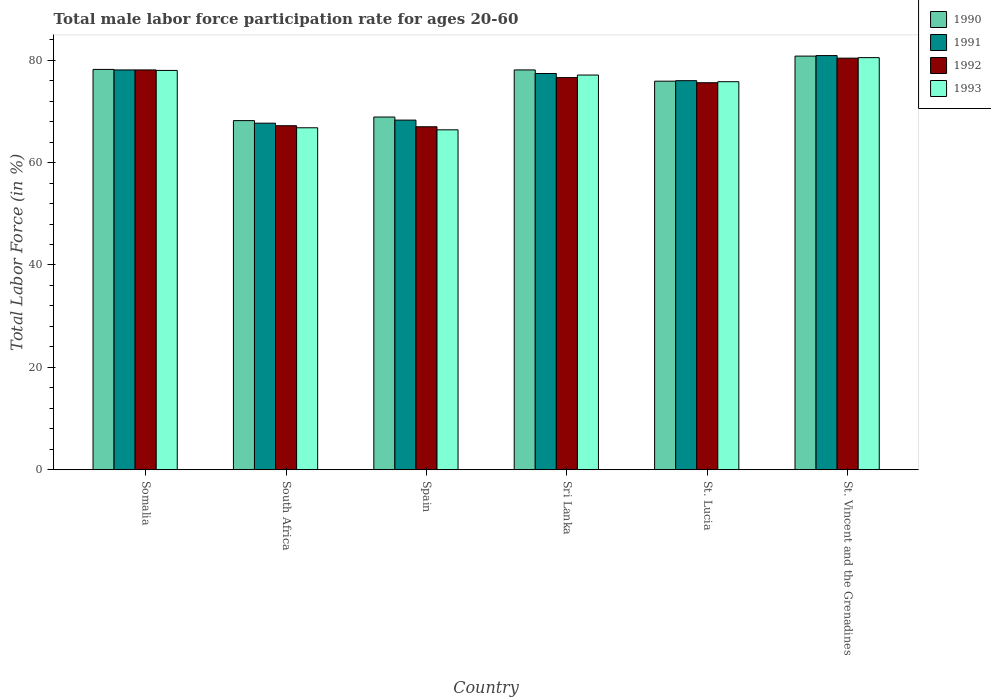How many groups of bars are there?
Keep it short and to the point. 6. What is the label of the 3rd group of bars from the left?
Make the answer very short. Spain. What is the male labor force participation rate in 1991 in Sri Lanka?
Keep it short and to the point. 77.4. Across all countries, what is the maximum male labor force participation rate in 1991?
Provide a short and direct response. 80.9. Across all countries, what is the minimum male labor force participation rate in 1990?
Your answer should be very brief. 68.2. In which country was the male labor force participation rate in 1991 maximum?
Your answer should be very brief. St. Vincent and the Grenadines. In which country was the male labor force participation rate in 1990 minimum?
Your answer should be compact. South Africa. What is the total male labor force participation rate in 1991 in the graph?
Provide a succinct answer. 448.4. What is the difference between the male labor force participation rate in 1990 in South Africa and that in St. Lucia?
Offer a terse response. -7.7. What is the difference between the male labor force participation rate in 1992 in St. Vincent and the Grenadines and the male labor force participation rate in 1990 in South Africa?
Provide a succinct answer. 12.2. What is the average male labor force participation rate in 1993 per country?
Make the answer very short. 74.1. What is the difference between the male labor force participation rate of/in 1990 and male labor force participation rate of/in 1991 in Spain?
Offer a very short reply. 0.6. In how many countries, is the male labor force participation rate in 1993 greater than 12 %?
Offer a terse response. 6. What is the ratio of the male labor force participation rate in 1990 in Somalia to that in Sri Lanka?
Your response must be concise. 1. Is the difference between the male labor force participation rate in 1990 in Spain and Sri Lanka greater than the difference between the male labor force participation rate in 1991 in Spain and Sri Lanka?
Offer a terse response. No. What is the difference between the highest and the second highest male labor force participation rate in 1990?
Provide a short and direct response. 2.7. What is the difference between the highest and the lowest male labor force participation rate in 1990?
Your answer should be compact. 12.6. In how many countries, is the male labor force participation rate in 1991 greater than the average male labor force participation rate in 1991 taken over all countries?
Your answer should be very brief. 4. Is it the case that in every country, the sum of the male labor force participation rate in 1990 and male labor force participation rate in 1993 is greater than the sum of male labor force participation rate in 1991 and male labor force participation rate in 1992?
Provide a short and direct response. No. What does the 4th bar from the left in Sri Lanka represents?
Ensure brevity in your answer.  1993. What does the 3rd bar from the right in St. Vincent and the Grenadines represents?
Offer a very short reply. 1991. Is it the case that in every country, the sum of the male labor force participation rate in 1993 and male labor force participation rate in 1991 is greater than the male labor force participation rate in 1992?
Ensure brevity in your answer.  Yes. Are all the bars in the graph horizontal?
Keep it short and to the point. No. What is the difference between two consecutive major ticks on the Y-axis?
Give a very brief answer. 20. Where does the legend appear in the graph?
Give a very brief answer. Top right. How are the legend labels stacked?
Offer a terse response. Vertical. What is the title of the graph?
Your answer should be very brief. Total male labor force participation rate for ages 20-60. Does "1998" appear as one of the legend labels in the graph?
Provide a succinct answer. No. What is the label or title of the X-axis?
Offer a terse response. Country. What is the label or title of the Y-axis?
Give a very brief answer. Total Labor Force (in %). What is the Total Labor Force (in %) in 1990 in Somalia?
Ensure brevity in your answer.  78.2. What is the Total Labor Force (in %) of 1991 in Somalia?
Your answer should be compact. 78.1. What is the Total Labor Force (in %) of 1992 in Somalia?
Provide a succinct answer. 78.1. What is the Total Labor Force (in %) of 1990 in South Africa?
Give a very brief answer. 68.2. What is the Total Labor Force (in %) in 1991 in South Africa?
Offer a very short reply. 67.7. What is the Total Labor Force (in %) in 1992 in South Africa?
Ensure brevity in your answer.  67.2. What is the Total Labor Force (in %) in 1993 in South Africa?
Offer a very short reply. 66.8. What is the Total Labor Force (in %) of 1990 in Spain?
Provide a succinct answer. 68.9. What is the Total Labor Force (in %) in 1991 in Spain?
Ensure brevity in your answer.  68.3. What is the Total Labor Force (in %) in 1993 in Spain?
Offer a very short reply. 66.4. What is the Total Labor Force (in %) of 1990 in Sri Lanka?
Provide a succinct answer. 78.1. What is the Total Labor Force (in %) in 1991 in Sri Lanka?
Provide a short and direct response. 77.4. What is the Total Labor Force (in %) of 1992 in Sri Lanka?
Offer a very short reply. 76.6. What is the Total Labor Force (in %) of 1993 in Sri Lanka?
Give a very brief answer. 77.1. What is the Total Labor Force (in %) in 1990 in St. Lucia?
Your answer should be very brief. 75.9. What is the Total Labor Force (in %) in 1991 in St. Lucia?
Give a very brief answer. 76. What is the Total Labor Force (in %) of 1992 in St. Lucia?
Your response must be concise. 75.6. What is the Total Labor Force (in %) of 1993 in St. Lucia?
Your answer should be very brief. 75.8. What is the Total Labor Force (in %) in 1990 in St. Vincent and the Grenadines?
Offer a terse response. 80.8. What is the Total Labor Force (in %) in 1991 in St. Vincent and the Grenadines?
Ensure brevity in your answer.  80.9. What is the Total Labor Force (in %) of 1992 in St. Vincent and the Grenadines?
Make the answer very short. 80.4. What is the Total Labor Force (in %) of 1993 in St. Vincent and the Grenadines?
Your answer should be very brief. 80.5. Across all countries, what is the maximum Total Labor Force (in %) of 1990?
Provide a short and direct response. 80.8. Across all countries, what is the maximum Total Labor Force (in %) of 1991?
Your response must be concise. 80.9. Across all countries, what is the maximum Total Labor Force (in %) of 1992?
Ensure brevity in your answer.  80.4. Across all countries, what is the maximum Total Labor Force (in %) in 1993?
Provide a succinct answer. 80.5. Across all countries, what is the minimum Total Labor Force (in %) in 1990?
Your response must be concise. 68.2. Across all countries, what is the minimum Total Labor Force (in %) in 1991?
Ensure brevity in your answer.  67.7. Across all countries, what is the minimum Total Labor Force (in %) in 1992?
Your answer should be compact. 67. Across all countries, what is the minimum Total Labor Force (in %) of 1993?
Your answer should be very brief. 66.4. What is the total Total Labor Force (in %) in 1990 in the graph?
Make the answer very short. 450.1. What is the total Total Labor Force (in %) of 1991 in the graph?
Provide a succinct answer. 448.4. What is the total Total Labor Force (in %) of 1992 in the graph?
Your answer should be compact. 444.9. What is the total Total Labor Force (in %) of 1993 in the graph?
Ensure brevity in your answer.  444.6. What is the difference between the Total Labor Force (in %) of 1990 in Somalia and that in South Africa?
Make the answer very short. 10. What is the difference between the Total Labor Force (in %) in 1992 in Somalia and that in South Africa?
Provide a succinct answer. 10.9. What is the difference between the Total Labor Force (in %) in 1990 in Somalia and that in Spain?
Keep it short and to the point. 9.3. What is the difference between the Total Labor Force (in %) of 1992 in Somalia and that in Spain?
Make the answer very short. 11.1. What is the difference between the Total Labor Force (in %) of 1990 in Somalia and that in Sri Lanka?
Your answer should be very brief. 0.1. What is the difference between the Total Labor Force (in %) of 1991 in Somalia and that in Sri Lanka?
Give a very brief answer. 0.7. What is the difference between the Total Labor Force (in %) of 1992 in Somalia and that in Sri Lanka?
Your answer should be compact. 1.5. What is the difference between the Total Labor Force (in %) of 1993 in Somalia and that in Sri Lanka?
Give a very brief answer. 0.9. What is the difference between the Total Labor Force (in %) in 1991 in Somalia and that in St. Lucia?
Offer a terse response. 2.1. What is the difference between the Total Labor Force (in %) in 1992 in Somalia and that in St. Lucia?
Your answer should be compact. 2.5. What is the difference between the Total Labor Force (in %) of 1993 in Somalia and that in St. Lucia?
Provide a short and direct response. 2.2. What is the difference between the Total Labor Force (in %) of 1990 in Somalia and that in St. Vincent and the Grenadines?
Ensure brevity in your answer.  -2.6. What is the difference between the Total Labor Force (in %) in 1990 in South Africa and that in Spain?
Provide a short and direct response. -0.7. What is the difference between the Total Labor Force (in %) in 1990 in South Africa and that in Sri Lanka?
Provide a short and direct response. -9.9. What is the difference between the Total Labor Force (in %) in 1991 in South Africa and that in Sri Lanka?
Give a very brief answer. -9.7. What is the difference between the Total Labor Force (in %) in 1992 in South Africa and that in Sri Lanka?
Provide a short and direct response. -9.4. What is the difference between the Total Labor Force (in %) of 1993 in South Africa and that in Sri Lanka?
Provide a short and direct response. -10.3. What is the difference between the Total Labor Force (in %) of 1991 in South Africa and that in St. Lucia?
Provide a short and direct response. -8.3. What is the difference between the Total Labor Force (in %) of 1990 in South Africa and that in St. Vincent and the Grenadines?
Your answer should be very brief. -12.6. What is the difference between the Total Labor Force (in %) in 1991 in South Africa and that in St. Vincent and the Grenadines?
Ensure brevity in your answer.  -13.2. What is the difference between the Total Labor Force (in %) of 1992 in South Africa and that in St. Vincent and the Grenadines?
Offer a terse response. -13.2. What is the difference between the Total Labor Force (in %) of 1993 in South Africa and that in St. Vincent and the Grenadines?
Your answer should be compact. -13.7. What is the difference between the Total Labor Force (in %) of 1990 in Spain and that in Sri Lanka?
Your response must be concise. -9.2. What is the difference between the Total Labor Force (in %) of 1991 in Spain and that in Sri Lanka?
Your answer should be very brief. -9.1. What is the difference between the Total Labor Force (in %) in 1992 in Spain and that in Sri Lanka?
Give a very brief answer. -9.6. What is the difference between the Total Labor Force (in %) in 1993 in Spain and that in Sri Lanka?
Offer a very short reply. -10.7. What is the difference between the Total Labor Force (in %) in 1990 in Spain and that in St. Lucia?
Your answer should be compact. -7. What is the difference between the Total Labor Force (in %) in 1991 in Spain and that in St. Lucia?
Keep it short and to the point. -7.7. What is the difference between the Total Labor Force (in %) of 1992 in Spain and that in St. Lucia?
Provide a succinct answer. -8.6. What is the difference between the Total Labor Force (in %) in 1993 in Spain and that in St. Lucia?
Make the answer very short. -9.4. What is the difference between the Total Labor Force (in %) in 1990 in Spain and that in St. Vincent and the Grenadines?
Your answer should be compact. -11.9. What is the difference between the Total Labor Force (in %) of 1991 in Spain and that in St. Vincent and the Grenadines?
Provide a short and direct response. -12.6. What is the difference between the Total Labor Force (in %) of 1992 in Spain and that in St. Vincent and the Grenadines?
Your answer should be very brief. -13.4. What is the difference between the Total Labor Force (in %) of 1993 in Spain and that in St. Vincent and the Grenadines?
Ensure brevity in your answer.  -14.1. What is the difference between the Total Labor Force (in %) of 1992 in Sri Lanka and that in St. Vincent and the Grenadines?
Provide a succinct answer. -3.8. What is the difference between the Total Labor Force (in %) of 1993 in Sri Lanka and that in St. Vincent and the Grenadines?
Offer a terse response. -3.4. What is the difference between the Total Labor Force (in %) of 1990 in St. Lucia and that in St. Vincent and the Grenadines?
Keep it short and to the point. -4.9. What is the difference between the Total Labor Force (in %) in 1993 in St. Lucia and that in St. Vincent and the Grenadines?
Provide a succinct answer. -4.7. What is the difference between the Total Labor Force (in %) of 1990 in Somalia and the Total Labor Force (in %) of 1992 in South Africa?
Your answer should be very brief. 11. What is the difference between the Total Labor Force (in %) of 1990 in Somalia and the Total Labor Force (in %) of 1993 in Spain?
Provide a short and direct response. 11.8. What is the difference between the Total Labor Force (in %) of 1992 in Somalia and the Total Labor Force (in %) of 1993 in Spain?
Make the answer very short. 11.7. What is the difference between the Total Labor Force (in %) of 1990 in Somalia and the Total Labor Force (in %) of 1993 in Sri Lanka?
Provide a succinct answer. 1.1. What is the difference between the Total Labor Force (in %) in 1991 in Somalia and the Total Labor Force (in %) in 1992 in Sri Lanka?
Ensure brevity in your answer.  1.5. What is the difference between the Total Labor Force (in %) of 1991 in Somalia and the Total Labor Force (in %) of 1993 in Sri Lanka?
Offer a terse response. 1. What is the difference between the Total Labor Force (in %) of 1990 in Somalia and the Total Labor Force (in %) of 1991 in St. Lucia?
Offer a very short reply. 2.2. What is the difference between the Total Labor Force (in %) of 1990 in Somalia and the Total Labor Force (in %) of 1992 in St. Lucia?
Provide a succinct answer. 2.6. What is the difference between the Total Labor Force (in %) of 1992 in Somalia and the Total Labor Force (in %) of 1993 in St. Lucia?
Make the answer very short. 2.3. What is the difference between the Total Labor Force (in %) of 1990 in Somalia and the Total Labor Force (in %) of 1991 in St. Vincent and the Grenadines?
Offer a very short reply. -2.7. What is the difference between the Total Labor Force (in %) in 1990 in Somalia and the Total Labor Force (in %) in 1992 in St. Vincent and the Grenadines?
Your response must be concise. -2.2. What is the difference between the Total Labor Force (in %) of 1991 in Somalia and the Total Labor Force (in %) of 1992 in St. Vincent and the Grenadines?
Offer a terse response. -2.3. What is the difference between the Total Labor Force (in %) of 1991 in Somalia and the Total Labor Force (in %) of 1993 in St. Vincent and the Grenadines?
Make the answer very short. -2.4. What is the difference between the Total Labor Force (in %) of 1990 in South Africa and the Total Labor Force (in %) of 1991 in Spain?
Ensure brevity in your answer.  -0.1. What is the difference between the Total Labor Force (in %) in 1990 in South Africa and the Total Labor Force (in %) in 1993 in Spain?
Make the answer very short. 1.8. What is the difference between the Total Labor Force (in %) in 1991 in South Africa and the Total Labor Force (in %) in 1992 in Spain?
Your response must be concise. 0.7. What is the difference between the Total Labor Force (in %) of 1991 in South Africa and the Total Labor Force (in %) of 1993 in Spain?
Give a very brief answer. 1.3. What is the difference between the Total Labor Force (in %) of 1990 in South Africa and the Total Labor Force (in %) of 1991 in Sri Lanka?
Give a very brief answer. -9.2. What is the difference between the Total Labor Force (in %) in 1990 in South Africa and the Total Labor Force (in %) in 1991 in St. Lucia?
Keep it short and to the point. -7.8. What is the difference between the Total Labor Force (in %) of 1990 in South Africa and the Total Labor Force (in %) of 1993 in St. Lucia?
Offer a very short reply. -7.6. What is the difference between the Total Labor Force (in %) in 1991 in South Africa and the Total Labor Force (in %) in 1992 in St. Lucia?
Provide a succinct answer. -7.9. What is the difference between the Total Labor Force (in %) of 1992 in South Africa and the Total Labor Force (in %) of 1993 in St. Lucia?
Your response must be concise. -8.6. What is the difference between the Total Labor Force (in %) in 1990 in South Africa and the Total Labor Force (in %) in 1991 in St. Vincent and the Grenadines?
Provide a short and direct response. -12.7. What is the difference between the Total Labor Force (in %) in 1990 in South Africa and the Total Labor Force (in %) in 1992 in St. Vincent and the Grenadines?
Your answer should be compact. -12.2. What is the difference between the Total Labor Force (in %) in 1991 in South Africa and the Total Labor Force (in %) in 1993 in St. Vincent and the Grenadines?
Ensure brevity in your answer.  -12.8. What is the difference between the Total Labor Force (in %) of 1992 in South Africa and the Total Labor Force (in %) of 1993 in St. Vincent and the Grenadines?
Make the answer very short. -13.3. What is the difference between the Total Labor Force (in %) of 1990 in Spain and the Total Labor Force (in %) of 1993 in Sri Lanka?
Offer a terse response. -8.2. What is the difference between the Total Labor Force (in %) in 1991 in Spain and the Total Labor Force (in %) in 1993 in Sri Lanka?
Provide a succinct answer. -8.8. What is the difference between the Total Labor Force (in %) of 1992 in Spain and the Total Labor Force (in %) of 1993 in Sri Lanka?
Give a very brief answer. -10.1. What is the difference between the Total Labor Force (in %) of 1990 in Spain and the Total Labor Force (in %) of 1992 in St. Lucia?
Provide a succinct answer. -6.7. What is the difference between the Total Labor Force (in %) of 1990 in Spain and the Total Labor Force (in %) of 1993 in St. Lucia?
Your answer should be very brief. -6.9. What is the difference between the Total Labor Force (in %) of 1991 in Spain and the Total Labor Force (in %) of 1992 in St. Lucia?
Provide a short and direct response. -7.3. What is the difference between the Total Labor Force (in %) of 1991 in Spain and the Total Labor Force (in %) of 1993 in St. Lucia?
Offer a very short reply. -7.5. What is the difference between the Total Labor Force (in %) of 1990 in Spain and the Total Labor Force (in %) of 1991 in St. Vincent and the Grenadines?
Provide a succinct answer. -12. What is the difference between the Total Labor Force (in %) in 1991 in Spain and the Total Labor Force (in %) in 1993 in St. Vincent and the Grenadines?
Offer a terse response. -12.2. What is the difference between the Total Labor Force (in %) of 1992 in Spain and the Total Labor Force (in %) of 1993 in St. Vincent and the Grenadines?
Provide a short and direct response. -13.5. What is the difference between the Total Labor Force (in %) of 1990 in Sri Lanka and the Total Labor Force (in %) of 1992 in St. Lucia?
Keep it short and to the point. 2.5. What is the difference between the Total Labor Force (in %) in 1992 in Sri Lanka and the Total Labor Force (in %) in 1993 in St. Lucia?
Ensure brevity in your answer.  0.8. What is the difference between the Total Labor Force (in %) of 1990 in Sri Lanka and the Total Labor Force (in %) of 1992 in St. Vincent and the Grenadines?
Make the answer very short. -2.3. What is the difference between the Total Labor Force (in %) in 1990 in Sri Lanka and the Total Labor Force (in %) in 1993 in St. Vincent and the Grenadines?
Provide a succinct answer. -2.4. What is the difference between the Total Labor Force (in %) in 1991 in Sri Lanka and the Total Labor Force (in %) in 1992 in St. Vincent and the Grenadines?
Offer a terse response. -3. What is the difference between the Total Labor Force (in %) of 1991 in Sri Lanka and the Total Labor Force (in %) of 1993 in St. Vincent and the Grenadines?
Make the answer very short. -3.1. What is the difference between the Total Labor Force (in %) in 1990 in St. Lucia and the Total Labor Force (in %) in 1991 in St. Vincent and the Grenadines?
Provide a succinct answer. -5. What is the difference between the Total Labor Force (in %) of 1990 in St. Lucia and the Total Labor Force (in %) of 1993 in St. Vincent and the Grenadines?
Provide a succinct answer. -4.6. What is the difference between the Total Labor Force (in %) of 1991 in St. Lucia and the Total Labor Force (in %) of 1992 in St. Vincent and the Grenadines?
Make the answer very short. -4.4. What is the difference between the Total Labor Force (in %) in 1992 in St. Lucia and the Total Labor Force (in %) in 1993 in St. Vincent and the Grenadines?
Offer a terse response. -4.9. What is the average Total Labor Force (in %) of 1990 per country?
Your answer should be very brief. 75.02. What is the average Total Labor Force (in %) in 1991 per country?
Your answer should be compact. 74.73. What is the average Total Labor Force (in %) of 1992 per country?
Your response must be concise. 74.15. What is the average Total Labor Force (in %) of 1993 per country?
Your answer should be compact. 74.1. What is the difference between the Total Labor Force (in %) of 1990 and Total Labor Force (in %) of 1993 in Somalia?
Give a very brief answer. 0.2. What is the difference between the Total Labor Force (in %) in 1991 and Total Labor Force (in %) in 1992 in Somalia?
Give a very brief answer. 0. What is the difference between the Total Labor Force (in %) in 1991 and Total Labor Force (in %) in 1993 in Somalia?
Give a very brief answer. 0.1. What is the difference between the Total Labor Force (in %) of 1990 and Total Labor Force (in %) of 1992 in South Africa?
Your answer should be very brief. 1. What is the difference between the Total Labor Force (in %) of 1991 and Total Labor Force (in %) of 1993 in South Africa?
Offer a very short reply. 0.9. What is the difference between the Total Labor Force (in %) in 1990 and Total Labor Force (in %) in 1991 in Spain?
Provide a succinct answer. 0.6. What is the difference between the Total Labor Force (in %) of 1990 and Total Labor Force (in %) of 1992 in Spain?
Your answer should be very brief. 1.9. What is the difference between the Total Labor Force (in %) of 1992 and Total Labor Force (in %) of 1993 in Spain?
Your answer should be compact. 0.6. What is the difference between the Total Labor Force (in %) of 1990 and Total Labor Force (in %) of 1991 in Sri Lanka?
Offer a terse response. 0.7. What is the difference between the Total Labor Force (in %) in 1990 and Total Labor Force (in %) in 1992 in Sri Lanka?
Offer a very short reply. 1.5. What is the difference between the Total Labor Force (in %) of 1992 and Total Labor Force (in %) of 1993 in Sri Lanka?
Ensure brevity in your answer.  -0.5. What is the difference between the Total Labor Force (in %) in 1990 and Total Labor Force (in %) in 1991 in St. Lucia?
Provide a short and direct response. -0.1. What is the difference between the Total Labor Force (in %) in 1990 and Total Labor Force (in %) in 1992 in St. Lucia?
Keep it short and to the point. 0.3. What is the difference between the Total Labor Force (in %) of 1991 and Total Labor Force (in %) of 1992 in St. Lucia?
Keep it short and to the point. 0.4. What is the difference between the Total Labor Force (in %) in 1992 and Total Labor Force (in %) in 1993 in St. Lucia?
Offer a terse response. -0.2. What is the difference between the Total Labor Force (in %) of 1992 and Total Labor Force (in %) of 1993 in St. Vincent and the Grenadines?
Ensure brevity in your answer.  -0.1. What is the ratio of the Total Labor Force (in %) of 1990 in Somalia to that in South Africa?
Provide a short and direct response. 1.15. What is the ratio of the Total Labor Force (in %) in 1991 in Somalia to that in South Africa?
Provide a succinct answer. 1.15. What is the ratio of the Total Labor Force (in %) of 1992 in Somalia to that in South Africa?
Your answer should be compact. 1.16. What is the ratio of the Total Labor Force (in %) of 1993 in Somalia to that in South Africa?
Offer a very short reply. 1.17. What is the ratio of the Total Labor Force (in %) of 1990 in Somalia to that in Spain?
Your answer should be compact. 1.14. What is the ratio of the Total Labor Force (in %) of 1991 in Somalia to that in Spain?
Offer a very short reply. 1.14. What is the ratio of the Total Labor Force (in %) of 1992 in Somalia to that in Spain?
Offer a terse response. 1.17. What is the ratio of the Total Labor Force (in %) in 1993 in Somalia to that in Spain?
Your answer should be compact. 1.17. What is the ratio of the Total Labor Force (in %) of 1991 in Somalia to that in Sri Lanka?
Keep it short and to the point. 1.01. What is the ratio of the Total Labor Force (in %) in 1992 in Somalia to that in Sri Lanka?
Give a very brief answer. 1.02. What is the ratio of the Total Labor Force (in %) of 1993 in Somalia to that in Sri Lanka?
Ensure brevity in your answer.  1.01. What is the ratio of the Total Labor Force (in %) of 1990 in Somalia to that in St. Lucia?
Your answer should be very brief. 1.03. What is the ratio of the Total Labor Force (in %) in 1991 in Somalia to that in St. Lucia?
Ensure brevity in your answer.  1.03. What is the ratio of the Total Labor Force (in %) of 1992 in Somalia to that in St. Lucia?
Give a very brief answer. 1.03. What is the ratio of the Total Labor Force (in %) in 1990 in Somalia to that in St. Vincent and the Grenadines?
Give a very brief answer. 0.97. What is the ratio of the Total Labor Force (in %) of 1991 in Somalia to that in St. Vincent and the Grenadines?
Keep it short and to the point. 0.97. What is the ratio of the Total Labor Force (in %) in 1992 in Somalia to that in St. Vincent and the Grenadines?
Offer a terse response. 0.97. What is the ratio of the Total Labor Force (in %) in 1993 in Somalia to that in St. Vincent and the Grenadines?
Offer a terse response. 0.97. What is the ratio of the Total Labor Force (in %) of 1990 in South Africa to that in Spain?
Provide a succinct answer. 0.99. What is the ratio of the Total Labor Force (in %) in 1993 in South Africa to that in Spain?
Provide a succinct answer. 1.01. What is the ratio of the Total Labor Force (in %) of 1990 in South Africa to that in Sri Lanka?
Your answer should be very brief. 0.87. What is the ratio of the Total Labor Force (in %) of 1991 in South Africa to that in Sri Lanka?
Ensure brevity in your answer.  0.87. What is the ratio of the Total Labor Force (in %) in 1992 in South Africa to that in Sri Lanka?
Offer a very short reply. 0.88. What is the ratio of the Total Labor Force (in %) in 1993 in South Africa to that in Sri Lanka?
Provide a short and direct response. 0.87. What is the ratio of the Total Labor Force (in %) of 1990 in South Africa to that in St. Lucia?
Ensure brevity in your answer.  0.9. What is the ratio of the Total Labor Force (in %) in 1991 in South Africa to that in St. Lucia?
Make the answer very short. 0.89. What is the ratio of the Total Labor Force (in %) in 1992 in South Africa to that in St. Lucia?
Keep it short and to the point. 0.89. What is the ratio of the Total Labor Force (in %) of 1993 in South Africa to that in St. Lucia?
Offer a very short reply. 0.88. What is the ratio of the Total Labor Force (in %) in 1990 in South Africa to that in St. Vincent and the Grenadines?
Provide a succinct answer. 0.84. What is the ratio of the Total Labor Force (in %) in 1991 in South Africa to that in St. Vincent and the Grenadines?
Make the answer very short. 0.84. What is the ratio of the Total Labor Force (in %) of 1992 in South Africa to that in St. Vincent and the Grenadines?
Your answer should be very brief. 0.84. What is the ratio of the Total Labor Force (in %) of 1993 in South Africa to that in St. Vincent and the Grenadines?
Your answer should be compact. 0.83. What is the ratio of the Total Labor Force (in %) in 1990 in Spain to that in Sri Lanka?
Keep it short and to the point. 0.88. What is the ratio of the Total Labor Force (in %) of 1991 in Spain to that in Sri Lanka?
Your response must be concise. 0.88. What is the ratio of the Total Labor Force (in %) of 1992 in Spain to that in Sri Lanka?
Your answer should be compact. 0.87. What is the ratio of the Total Labor Force (in %) of 1993 in Spain to that in Sri Lanka?
Keep it short and to the point. 0.86. What is the ratio of the Total Labor Force (in %) of 1990 in Spain to that in St. Lucia?
Make the answer very short. 0.91. What is the ratio of the Total Labor Force (in %) in 1991 in Spain to that in St. Lucia?
Ensure brevity in your answer.  0.9. What is the ratio of the Total Labor Force (in %) of 1992 in Spain to that in St. Lucia?
Make the answer very short. 0.89. What is the ratio of the Total Labor Force (in %) of 1993 in Spain to that in St. Lucia?
Ensure brevity in your answer.  0.88. What is the ratio of the Total Labor Force (in %) of 1990 in Spain to that in St. Vincent and the Grenadines?
Keep it short and to the point. 0.85. What is the ratio of the Total Labor Force (in %) in 1991 in Spain to that in St. Vincent and the Grenadines?
Give a very brief answer. 0.84. What is the ratio of the Total Labor Force (in %) of 1992 in Spain to that in St. Vincent and the Grenadines?
Ensure brevity in your answer.  0.83. What is the ratio of the Total Labor Force (in %) in 1993 in Spain to that in St. Vincent and the Grenadines?
Your answer should be very brief. 0.82. What is the ratio of the Total Labor Force (in %) of 1990 in Sri Lanka to that in St. Lucia?
Make the answer very short. 1.03. What is the ratio of the Total Labor Force (in %) in 1991 in Sri Lanka to that in St. Lucia?
Your answer should be very brief. 1.02. What is the ratio of the Total Labor Force (in %) in 1992 in Sri Lanka to that in St. Lucia?
Give a very brief answer. 1.01. What is the ratio of the Total Labor Force (in %) in 1993 in Sri Lanka to that in St. Lucia?
Your answer should be compact. 1.02. What is the ratio of the Total Labor Force (in %) of 1990 in Sri Lanka to that in St. Vincent and the Grenadines?
Keep it short and to the point. 0.97. What is the ratio of the Total Labor Force (in %) in 1991 in Sri Lanka to that in St. Vincent and the Grenadines?
Your answer should be very brief. 0.96. What is the ratio of the Total Labor Force (in %) in 1992 in Sri Lanka to that in St. Vincent and the Grenadines?
Provide a succinct answer. 0.95. What is the ratio of the Total Labor Force (in %) of 1993 in Sri Lanka to that in St. Vincent and the Grenadines?
Offer a terse response. 0.96. What is the ratio of the Total Labor Force (in %) in 1990 in St. Lucia to that in St. Vincent and the Grenadines?
Make the answer very short. 0.94. What is the ratio of the Total Labor Force (in %) in 1991 in St. Lucia to that in St. Vincent and the Grenadines?
Ensure brevity in your answer.  0.94. What is the ratio of the Total Labor Force (in %) of 1992 in St. Lucia to that in St. Vincent and the Grenadines?
Give a very brief answer. 0.94. What is the ratio of the Total Labor Force (in %) in 1993 in St. Lucia to that in St. Vincent and the Grenadines?
Ensure brevity in your answer.  0.94. What is the difference between the highest and the second highest Total Labor Force (in %) in 1990?
Keep it short and to the point. 2.6. What is the difference between the highest and the lowest Total Labor Force (in %) in 1990?
Keep it short and to the point. 12.6. What is the difference between the highest and the lowest Total Labor Force (in %) in 1991?
Your answer should be compact. 13.2. What is the difference between the highest and the lowest Total Labor Force (in %) of 1992?
Keep it short and to the point. 13.4. 